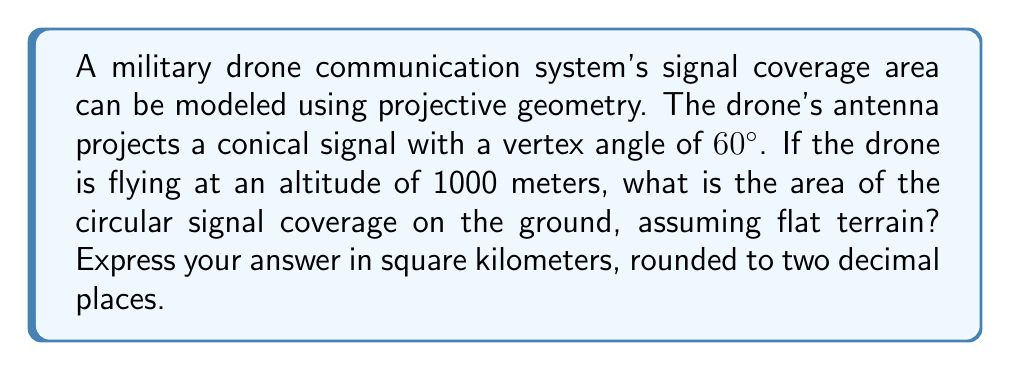Show me your answer to this math problem. Let's approach this step-by-step using projective geometry concepts:

1) First, we need to visualize the problem. The drone's signal forms a cone, and we're interested in the circular base of this cone where it intersects the ground.

2) In projective geometry, we can model this as a conic section. The circle on the ground is a planar slice of the cone.

3) The key to solving this problem is to find the radius of the circular coverage area. We can do this using trigonometry.

4) Let's define our variables:
   $h$ = height of the drone = 1000 meters
   $\theta$ = half of the vertex angle = 30° (since the full vertex angle is 60°)

5) The radius $r$ of the circular coverage area can be found using the tangent function:

   $$\tan(\theta) = \frac{r}{h}$$

6) Rearranging this equation:

   $$r = h \cdot \tan(\theta)$$

7) Plugging in our values:

   $$r = 1000 \cdot \tan(30°) = 1000 \cdot \frac{\sqrt{3}}{3} \approx 577.35 \text{ meters}$$

8) Now that we have the radius, we can calculate the area of the circle using the formula $A = \pi r^2$:

   $$A = \pi \cdot (577.35)^2 \approx 1,047,197.55 \text{ square meters}$$

9) Converting to square kilometers:

   $$1,047,197.55 \text{ m}^2 = 1.05 \text{ km}^2$$ (rounded to two decimal places)
Answer: 1.05 km² 